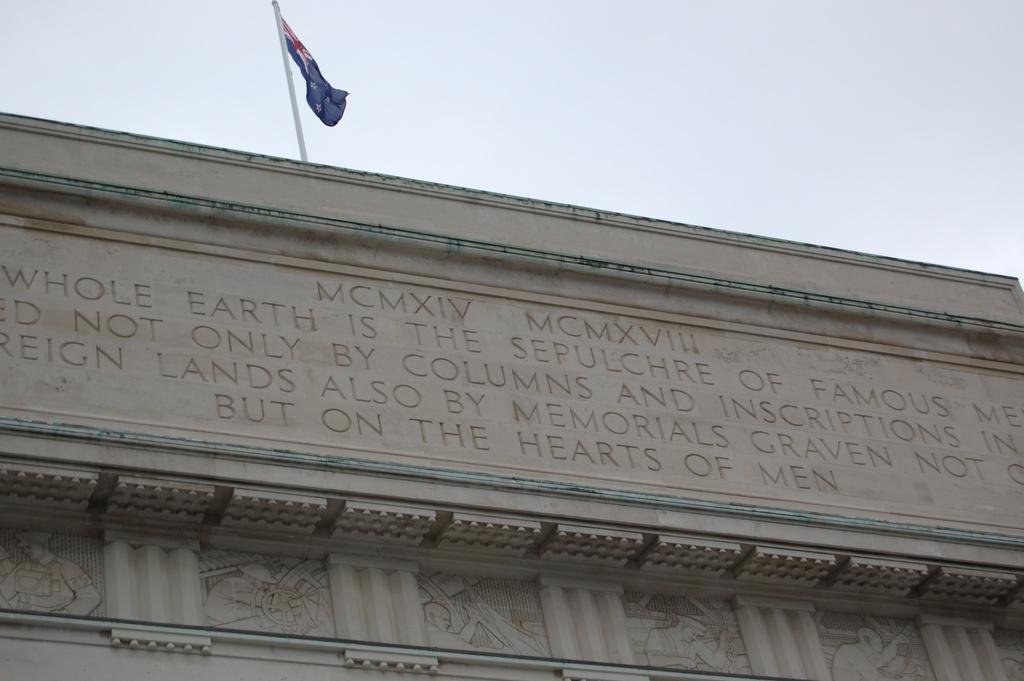What is the main subject in the center of the image? There is a building in the center of the image. What can be seen on the building? There is text and art on the building. Are there any additional features on the building? Yes, there is a pole and a flag on the building. What is visible at the top of the image? The sky is visible at the top of the image. What time of day is it in the image, considering the afternoon? The provided facts do not mention the time of day, so it cannot be determined if it is afternoon or not. --- Facts: 1. There is a person sitting on a bench in the image. 2. The person is reading a book. 3. There is a tree behind the bench. 4. The sky is visible in the background. 5. There is a path leading to the bench. Absurd Topics: parrot, ocean, dance Conversation: What is the person in the image doing? The person is sitting on a bench and reading a book. What can be seen behind the bench? There is a tree behind the bench. What is visible in the background of the image? The sky is visible in the background. How can someone reach the bench in the image? There is a path leading to the bench. Reasoning: Let's think step by step in order to produce the conversation. We start by identifying the main subject in the image, which is the person sitting on the bench. Then, we expand the conversation to include other details about the person's activity, the surrounding environment, and the path leading to the bench. Each question is designed to elicit a specific detail about the image that is known from the provided facts. Absurd Question/Answer: Can you see any parrots flying over the ocean in the image? There is no mention of parrots or the ocean in the provided facts, so it cannot be determined if they are present in the image. 